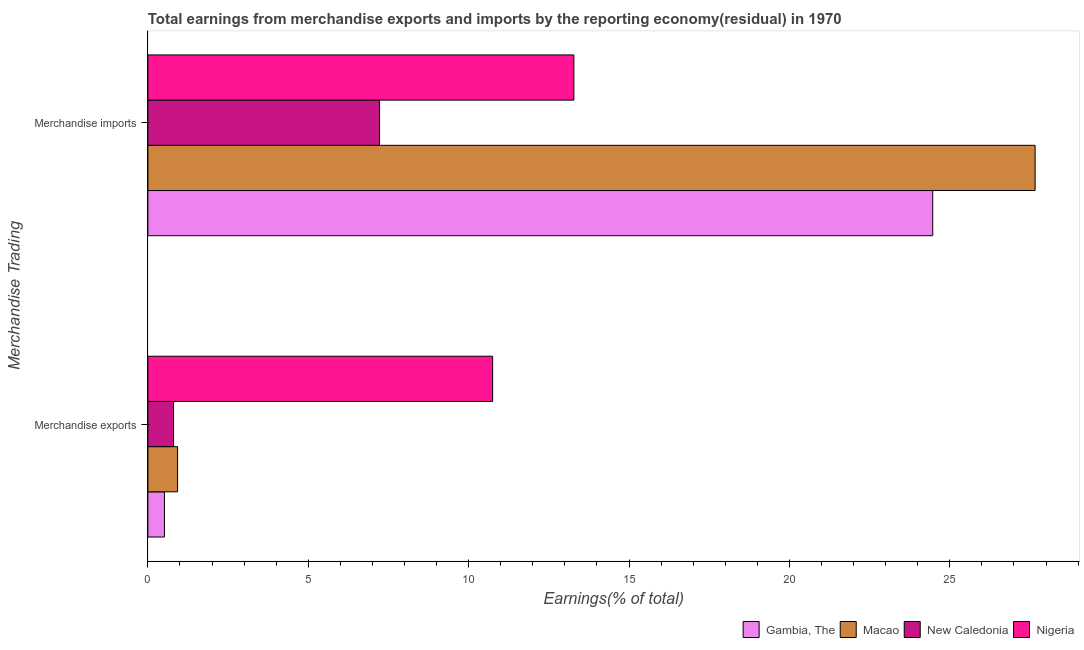How many groups of bars are there?
Your answer should be compact. 2. Are the number of bars on each tick of the Y-axis equal?
Provide a short and direct response. Yes. How many bars are there on the 1st tick from the top?
Provide a short and direct response. 4. How many bars are there on the 1st tick from the bottom?
Keep it short and to the point. 4. What is the label of the 2nd group of bars from the top?
Your answer should be compact. Merchandise exports. What is the earnings from merchandise exports in New Caledonia?
Your answer should be compact. 0.8. Across all countries, what is the maximum earnings from merchandise imports?
Your answer should be very brief. 27.66. Across all countries, what is the minimum earnings from merchandise exports?
Your answer should be very brief. 0.52. In which country was the earnings from merchandise exports maximum?
Make the answer very short. Nigeria. In which country was the earnings from merchandise exports minimum?
Your response must be concise. Gambia, The. What is the total earnings from merchandise exports in the graph?
Provide a succinct answer. 12.99. What is the difference between the earnings from merchandise imports in Nigeria and that in Gambia, The?
Keep it short and to the point. -11.19. What is the difference between the earnings from merchandise exports in New Caledonia and the earnings from merchandise imports in Gambia, The?
Your response must be concise. -23.67. What is the average earnings from merchandise imports per country?
Give a very brief answer. 18.16. What is the difference between the earnings from merchandise imports and earnings from merchandise exports in Gambia, The?
Offer a very short reply. 23.95. What is the ratio of the earnings from merchandise imports in Nigeria to that in Macao?
Offer a very short reply. 0.48. Is the earnings from merchandise imports in New Caledonia less than that in Gambia, The?
Give a very brief answer. Yes. In how many countries, is the earnings from merchandise imports greater than the average earnings from merchandise imports taken over all countries?
Ensure brevity in your answer.  2. What does the 2nd bar from the top in Merchandise imports represents?
Your response must be concise. New Caledonia. What does the 3rd bar from the bottom in Merchandise imports represents?
Ensure brevity in your answer.  New Caledonia. How many countries are there in the graph?
Your answer should be compact. 4. What is the difference between two consecutive major ticks on the X-axis?
Your answer should be very brief. 5. Are the values on the major ticks of X-axis written in scientific E-notation?
Offer a very short reply. No. Does the graph contain any zero values?
Offer a terse response. No. Where does the legend appear in the graph?
Provide a short and direct response. Bottom right. How many legend labels are there?
Your answer should be very brief. 4. How are the legend labels stacked?
Provide a succinct answer. Horizontal. What is the title of the graph?
Make the answer very short. Total earnings from merchandise exports and imports by the reporting economy(residual) in 1970. Does "Maldives" appear as one of the legend labels in the graph?
Your response must be concise. No. What is the label or title of the X-axis?
Offer a terse response. Earnings(% of total). What is the label or title of the Y-axis?
Provide a succinct answer. Merchandise Trading. What is the Earnings(% of total) of Gambia, The in Merchandise exports?
Your answer should be compact. 0.52. What is the Earnings(% of total) in Macao in Merchandise exports?
Offer a very short reply. 0.93. What is the Earnings(% of total) in New Caledonia in Merchandise exports?
Your response must be concise. 0.8. What is the Earnings(% of total) of Nigeria in Merchandise exports?
Give a very brief answer. 10.75. What is the Earnings(% of total) of Gambia, The in Merchandise imports?
Your answer should be very brief. 24.47. What is the Earnings(% of total) in Macao in Merchandise imports?
Your answer should be very brief. 27.66. What is the Earnings(% of total) of New Caledonia in Merchandise imports?
Provide a short and direct response. 7.22. What is the Earnings(% of total) of Nigeria in Merchandise imports?
Ensure brevity in your answer.  13.28. Across all Merchandise Trading, what is the maximum Earnings(% of total) in Gambia, The?
Your answer should be very brief. 24.47. Across all Merchandise Trading, what is the maximum Earnings(% of total) of Macao?
Offer a very short reply. 27.66. Across all Merchandise Trading, what is the maximum Earnings(% of total) in New Caledonia?
Offer a very short reply. 7.22. Across all Merchandise Trading, what is the maximum Earnings(% of total) of Nigeria?
Give a very brief answer. 13.28. Across all Merchandise Trading, what is the minimum Earnings(% of total) of Gambia, The?
Your response must be concise. 0.52. Across all Merchandise Trading, what is the minimum Earnings(% of total) of Macao?
Give a very brief answer. 0.93. Across all Merchandise Trading, what is the minimum Earnings(% of total) of New Caledonia?
Provide a short and direct response. 0.8. Across all Merchandise Trading, what is the minimum Earnings(% of total) of Nigeria?
Provide a succinct answer. 10.75. What is the total Earnings(% of total) of Gambia, The in the graph?
Your answer should be very brief. 24.98. What is the total Earnings(% of total) of Macao in the graph?
Keep it short and to the point. 28.59. What is the total Earnings(% of total) in New Caledonia in the graph?
Ensure brevity in your answer.  8.02. What is the total Earnings(% of total) in Nigeria in the graph?
Provide a succinct answer. 24.03. What is the difference between the Earnings(% of total) in Gambia, The in Merchandise exports and that in Merchandise imports?
Offer a very short reply. -23.95. What is the difference between the Earnings(% of total) of Macao in Merchandise exports and that in Merchandise imports?
Provide a short and direct response. -26.73. What is the difference between the Earnings(% of total) in New Caledonia in Merchandise exports and that in Merchandise imports?
Give a very brief answer. -6.42. What is the difference between the Earnings(% of total) of Nigeria in Merchandise exports and that in Merchandise imports?
Offer a very short reply. -2.53. What is the difference between the Earnings(% of total) in Gambia, The in Merchandise exports and the Earnings(% of total) in Macao in Merchandise imports?
Your answer should be compact. -27.14. What is the difference between the Earnings(% of total) of Gambia, The in Merchandise exports and the Earnings(% of total) of New Caledonia in Merchandise imports?
Ensure brevity in your answer.  -6.71. What is the difference between the Earnings(% of total) of Gambia, The in Merchandise exports and the Earnings(% of total) of Nigeria in Merchandise imports?
Give a very brief answer. -12.76. What is the difference between the Earnings(% of total) of Macao in Merchandise exports and the Earnings(% of total) of New Caledonia in Merchandise imports?
Give a very brief answer. -6.3. What is the difference between the Earnings(% of total) of Macao in Merchandise exports and the Earnings(% of total) of Nigeria in Merchandise imports?
Your response must be concise. -12.35. What is the difference between the Earnings(% of total) of New Caledonia in Merchandise exports and the Earnings(% of total) of Nigeria in Merchandise imports?
Your response must be concise. -12.48. What is the average Earnings(% of total) of Gambia, The per Merchandise Trading?
Give a very brief answer. 12.49. What is the average Earnings(% of total) in Macao per Merchandise Trading?
Provide a succinct answer. 14.29. What is the average Earnings(% of total) of New Caledonia per Merchandise Trading?
Ensure brevity in your answer.  4.01. What is the average Earnings(% of total) in Nigeria per Merchandise Trading?
Provide a short and direct response. 12.01. What is the difference between the Earnings(% of total) in Gambia, The and Earnings(% of total) in Macao in Merchandise exports?
Provide a succinct answer. -0.41. What is the difference between the Earnings(% of total) in Gambia, The and Earnings(% of total) in New Caledonia in Merchandise exports?
Offer a terse response. -0.28. What is the difference between the Earnings(% of total) of Gambia, The and Earnings(% of total) of Nigeria in Merchandise exports?
Offer a very short reply. -10.23. What is the difference between the Earnings(% of total) in Macao and Earnings(% of total) in New Caledonia in Merchandise exports?
Offer a terse response. 0.13. What is the difference between the Earnings(% of total) of Macao and Earnings(% of total) of Nigeria in Merchandise exports?
Offer a very short reply. -9.82. What is the difference between the Earnings(% of total) in New Caledonia and Earnings(% of total) in Nigeria in Merchandise exports?
Your response must be concise. -9.95. What is the difference between the Earnings(% of total) of Gambia, The and Earnings(% of total) of Macao in Merchandise imports?
Ensure brevity in your answer.  -3.19. What is the difference between the Earnings(% of total) of Gambia, The and Earnings(% of total) of New Caledonia in Merchandise imports?
Offer a terse response. 17.25. What is the difference between the Earnings(% of total) in Gambia, The and Earnings(% of total) in Nigeria in Merchandise imports?
Give a very brief answer. 11.19. What is the difference between the Earnings(% of total) of Macao and Earnings(% of total) of New Caledonia in Merchandise imports?
Ensure brevity in your answer.  20.44. What is the difference between the Earnings(% of total) in Macao and Earnings(% of total) in Nigeria in Merchandise imports?
Offer a terse response. 14.38. What is the difference between the Earnings(% of total) of New Caledonia and Earnings(% of total) of Nigeria in Merchandise imports?
Offer a very short reply. -6.06. What is the ratio of the Earnings(% of total) of Gambia, The in Merchandise exports to that in Merchandise imports?
Provide a succinct answer. 0.02. What is the ratio of the Earnings(% of total) in Macao in Merchandise exports to that in Merchandise imports?
Provide a succinct answer. 0.03. What is the ratio of the Earnings(% of total) in New Caledonia in Merchandise exports to that in Merchandise imports?
Ensure brevity in your answer.  0.11. What is the ratio of the Earnings(% of total) in Nigeria in Merchandise exports to that in Merchandise imports?
Your answer should be very brief. 0.81. What is the difference between the highest and the second highest Earnings(% of total) in Gambia, The?
Ensure brevity in your answer.  23.95. What is the difference between the highest and the second highest Earnings(% of total) of Macao?
Provide a short and direct response. 26.73. What is the difference between the highest and the second highest Earnings(% of total) in New Caledonia?
Ensure brevity in your answer.  6.42. What is the difference between the highest and the second highest Earnings(% of total) in Nigeria?
Ensure brevity in your answer.  2.53. What is the difference between the highest and the lowest Earnings(% of total) of Gambia, The?
Offer a terse response. 23.95. What is the difference between the highest and the lowest Earnings(% of total) in Macao?
Offer a terse response. 26.73. What is the difference between the highest and the lowest Earnings(% of total) of New Caledonia?
Ensure brevity in your answer.  6.42. What is the difference between the highest and the lowest Earnings(% of total) in Nigeria?
Your response must be concise. 2.53. 